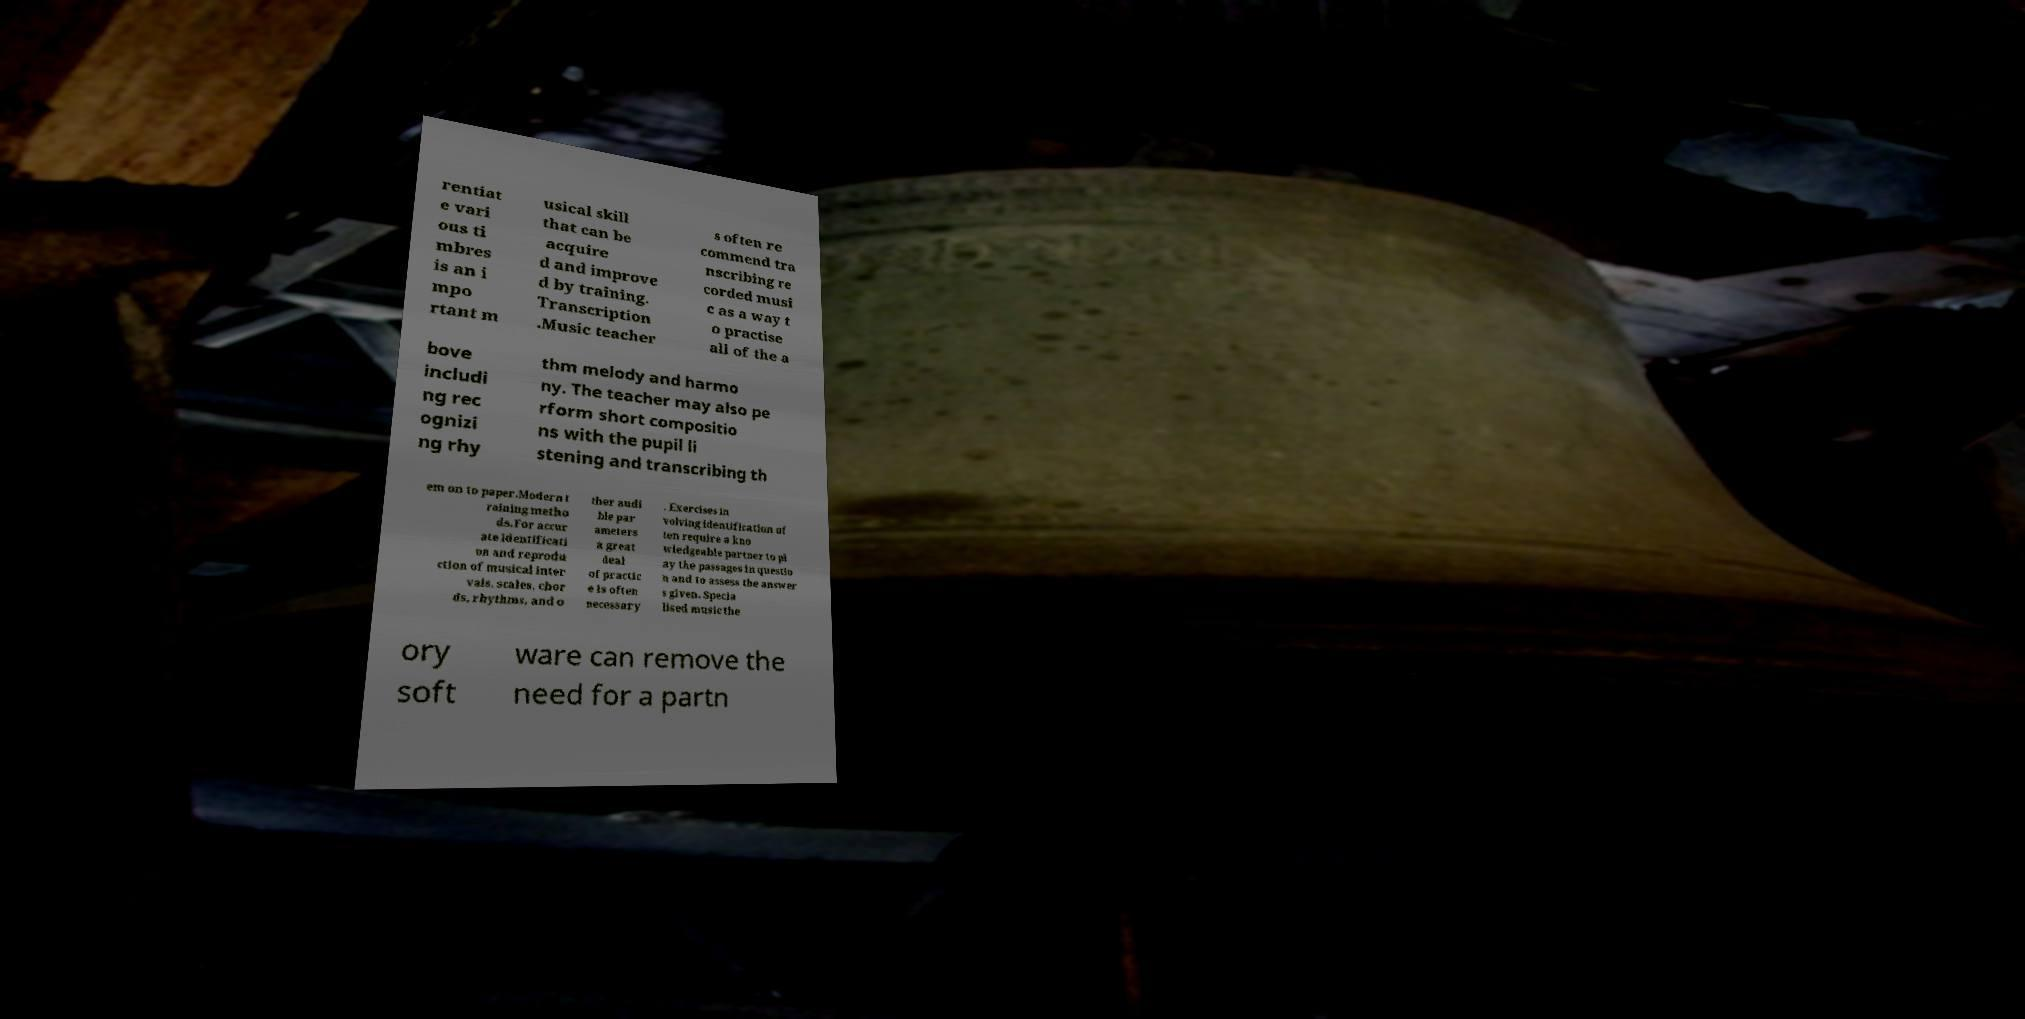Please identify and transcribe the text found in this image. rentiat e vari ous ti mbres is an i mpo rtant m usical skill that can be acquire d and improve d by training. Transcription .Music teacher s often re commend tra nscribing re corded musi c as a way t o practise all of the a bove includi ng rec ognizi ng rhy thm melody and harmo ny. The teacher may also pe rform short compositio ns with the pupil li stening and transcribing th em on to paper.Modern t raining metho ds.For accur ate identificati on and reprodu ction of musical inter vals, scales, chor ds, rhythms, and o ther audi ble par ameters a great deal of practic e is often necessary . Exercises in volving identification of ten require a kno wledgeable partner to pl ay the passages in questio n and to assess the answer s given. Specia lised music the ory soft ware can remove the need for a partn 